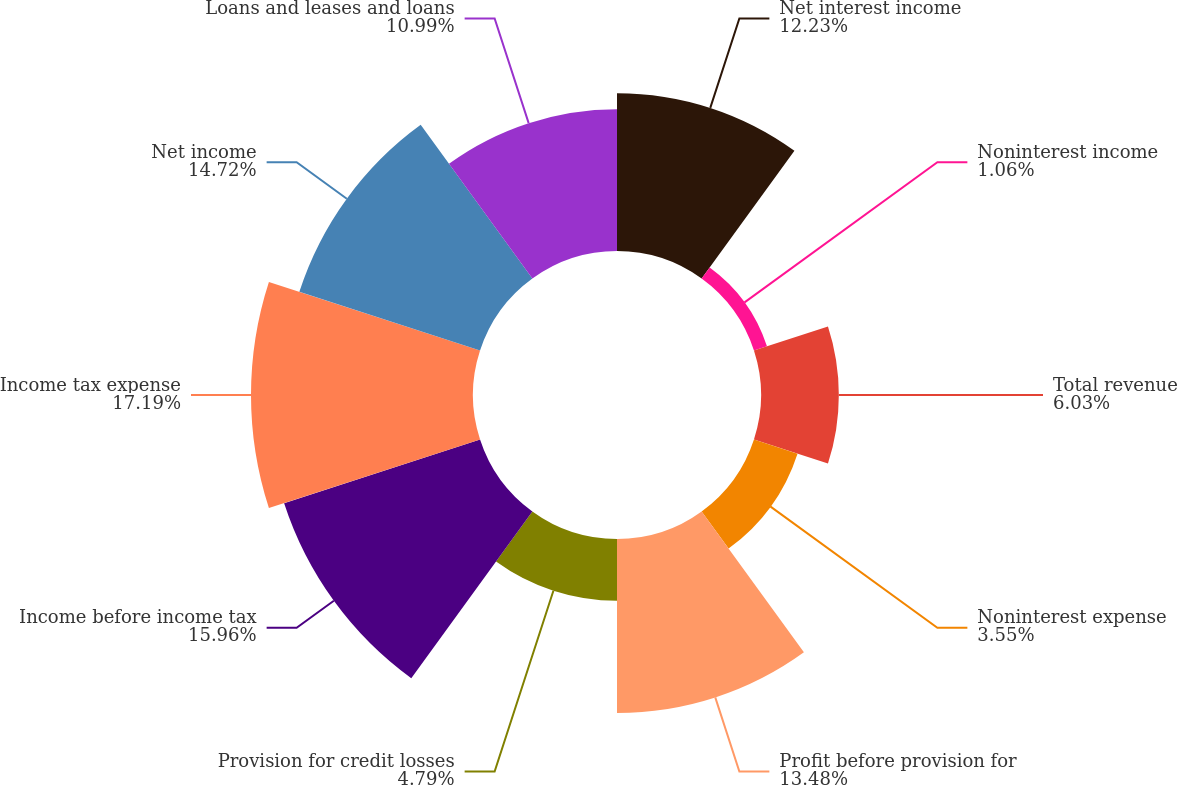<chart> <loc_0><loc_0><loc_500><loc_500><pie_chart><fcel>Net interest income<fcel>Noninterest income<fcel>Total revenue<fcel>Noninterest expense<fcel>Profit before provision for<fcel>Provision for credit losses<fcel>Income before income tax<fcel>Income tax expense<fcel>Net income<fcel>Loans and leases and loans<nl><fcel>12.23%<fcel>1.06%<fcel>6.03%<fcel>3.55%<fcel>13.48%<fcel>4.79%<fcel>15.96%<fcel>17.2%<fcel>14.72%<fcel>10.99%<nl></chart> 